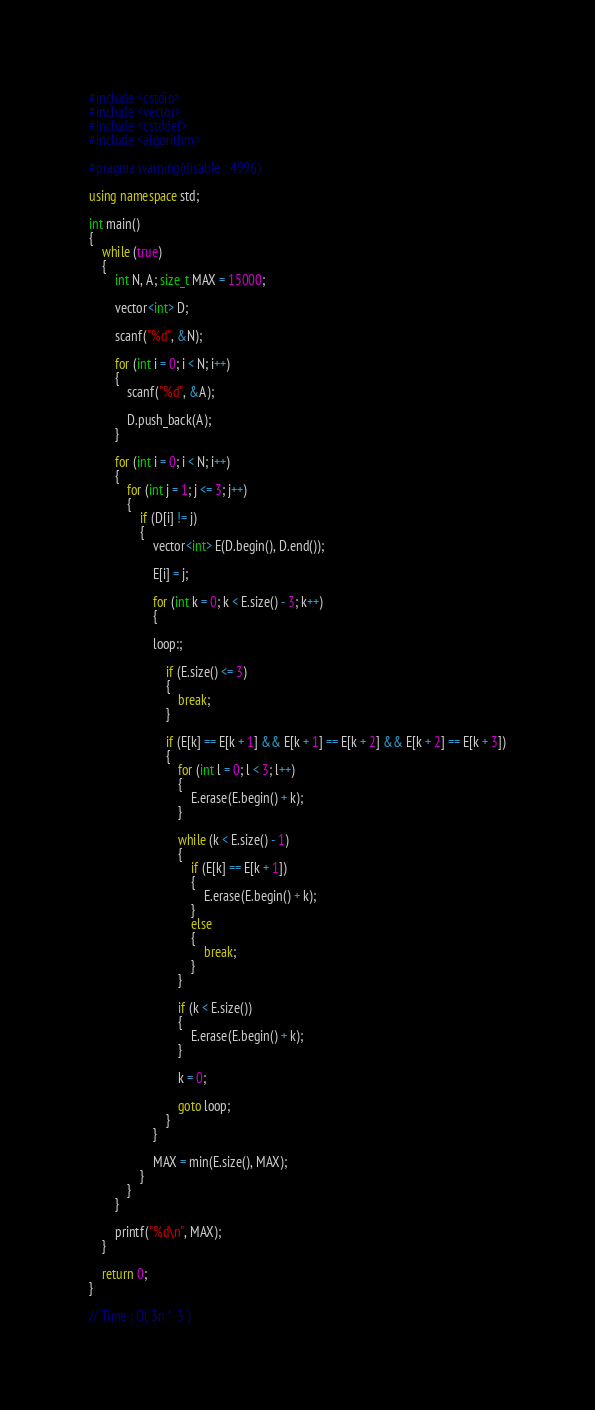<code> <loc_0><loc_0><loc_500><loc_500><_C++_>#include <cstdio>
#include <vector>
#include <cstddef>
#include <algorithm>

#pragma warning(disable : 4996)

using namespace std;

int main()
{
	while (true)
	{
		int N, A; size_t MAX = 15000;

		vector<int> D;

		scanf("%d", &N);

		for (int i = 0; i < N; i++)
		{
			scanf("%d", &A);

			D.push_back(A);
		}

		for (int i = 0; i < N; i++)
		{
			for (int j = 1; j <= 3; j++)
			{
				if (D[i] != j)
				{
					vector<int> E(D.begin(), D.end());

					E[i] = j;

					for (int k = 0; k < E.size() - 3; k++)
					{

					loop:;

						if (E.size() <= 3)
						{
							break;
						}

						if (E[k] == E[k + 1] && E[k + 1] == E[k + 2] && E[k + 2] == E[k + 3])
						{
							for (int l = 0; l < 3; l++)
							{
								E.erase(E.begin() + k);
							}

							while (k < E.size() - 1)
							{
								if (E[k] == E[k + 1])
								{
									E.erase(E.begin() + k);
								}
								else
								{
									break;
								}
							}

							if (k < E.size())
							{
								E.erase(E.begin() + k);
							}

							k = 0;

							goto loop;
						}
					}

					MAX = min(E.size(), MAX);
				}
			}
		}

		printf("%d\n", MAX);
	}

	return 0;
}

// Time : O( 3n ^ 3 )</code> 